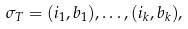<formula> <loc_0><loc_0><loc_500><loc_500>\sigma _ { T } = ( i _ { 1 } , b _ { 1 } ) , \dots , ( i _ { k } , b _ { k } ) ,</formula> 